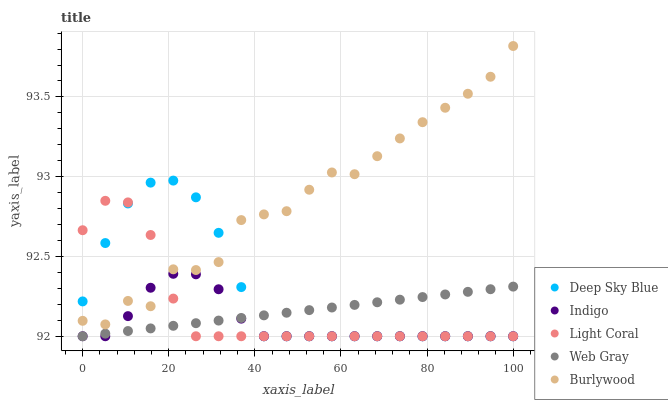Does Indigo have the minimum area under the curve?
Answer yes or no. Yes. Does Burlywood have the maximum area under the curve?
Answer yes or no. Yes. Does Web Gray have the minimum area under the curve?
Answer yes or no. No. Does Web Gray have the maximum area under the curve?
Answer yes or no. No. Is Web Gray the smoothest?
Answer yes or no. Yes. Is Burlywood the roughest?
Answer yes or no. Yes. Is Burlywood the smoothest?
Answer yes or no. No. Is Web Gray the roughest?
Answer yes or no. No. Does Light Coral have the lowest value?
Answer yes or no. Yes. Does Burlywood have the lowest value?
Answer yes or no. No. Does Burlywood have the highest value?
Answer yes or no. Yes. Does Web Gray have the highest value?
Answer yes or no. No. Is Web Gray less than Burlywood?
Answer yes or no. Yes. Is Burlywood greater than Web Gray?
Answer yes or no. Yes. Does Indigo intersect Burlywood?
Answer yes or no. Yes. Is Indigo less than Burlywood?
Answer yes or no. No. Is Indigo greater than Burlywood?
Answer yes or no. No. Does Web Gray intersect Burlywood?
Answer yes or no. No. 